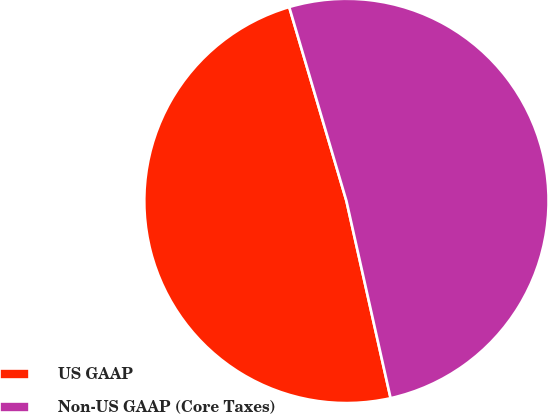Convert chart. <chart><loc_0><loc_0><loc_500><loc_500><pie_chart><fcel>US GAAP<fcel>Non-US GAAP (Core Taxes)<nl><fcel>48.94%<fcel>51.06%<nl></chart> 